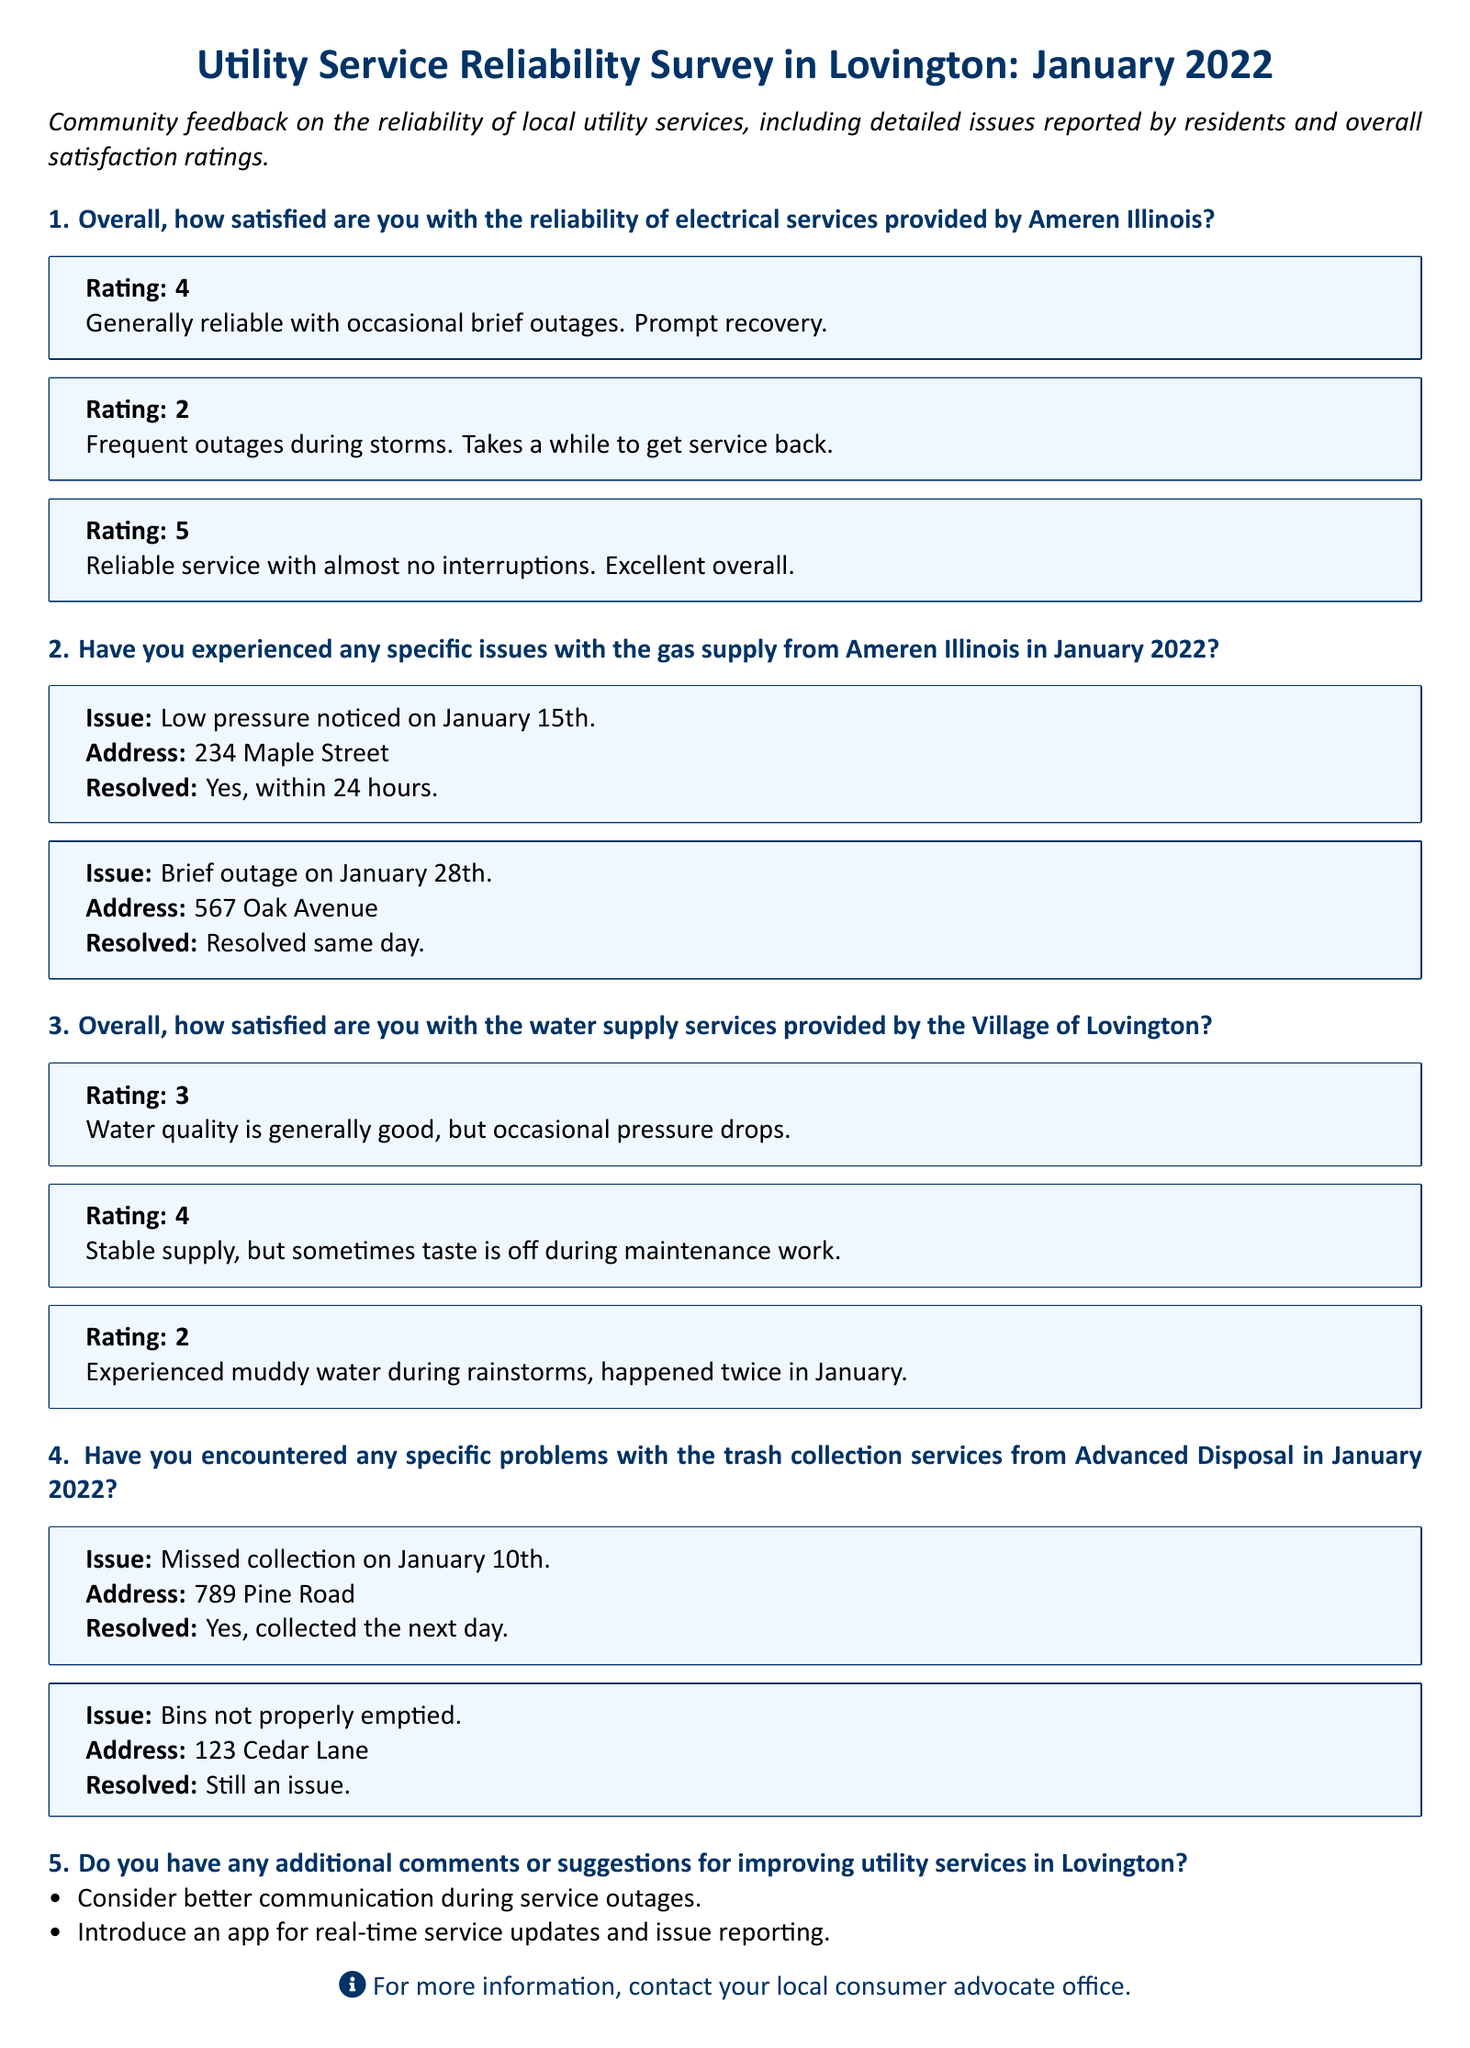What is the overall satisfaction rating for electrical services by Ameren Illinois? The overall satisfaction ratings are provided as numbers in the survey responses. The ratings include 4, 2, and 5.
Answer: 4, 2, 5 How many specific gas supply issues were reported in January 2022? The number of specific issues with the gas supply is indicated by the count of reported issues in the document. There are two issues reported.
Answer: 2 What was the address for the low-pressure issue reported on January 15th? The address is noted in the context of the specific issue reported. The address was 234 Maple Street.
Answer: 234 Maple Street What frequency of issues was reported regarding water supply? The document lists satisfaction ratings, including at least one mentioning water quality issues during rainstorms.
Answer: Occasional pressure drops, muddy water during rainstorms What issue is still unresolved concerning trash collection services? The document specifies unresolved issues related to the trash collection services, indicating that bins were not properly emptied.
Answer: Still an issue What suggestion was made for improving utility services? Suggestions are listed in the comments section, and one suggestion is related to communication during outages.
Answer: Better communication during service outages How quickly was the gas low-pressure issue resolved? The resolution time for reported issues is stated directly in the problem description. The low-pressure issue was resolved within 24 hours.
Answer: Within 24 hours What was the satisfaction rating for water supply services rated a 2? The document details responses and one water supply service response rated a 2 includes specific negative experiences.
Answer: Experienced muddy water during rainstorms 